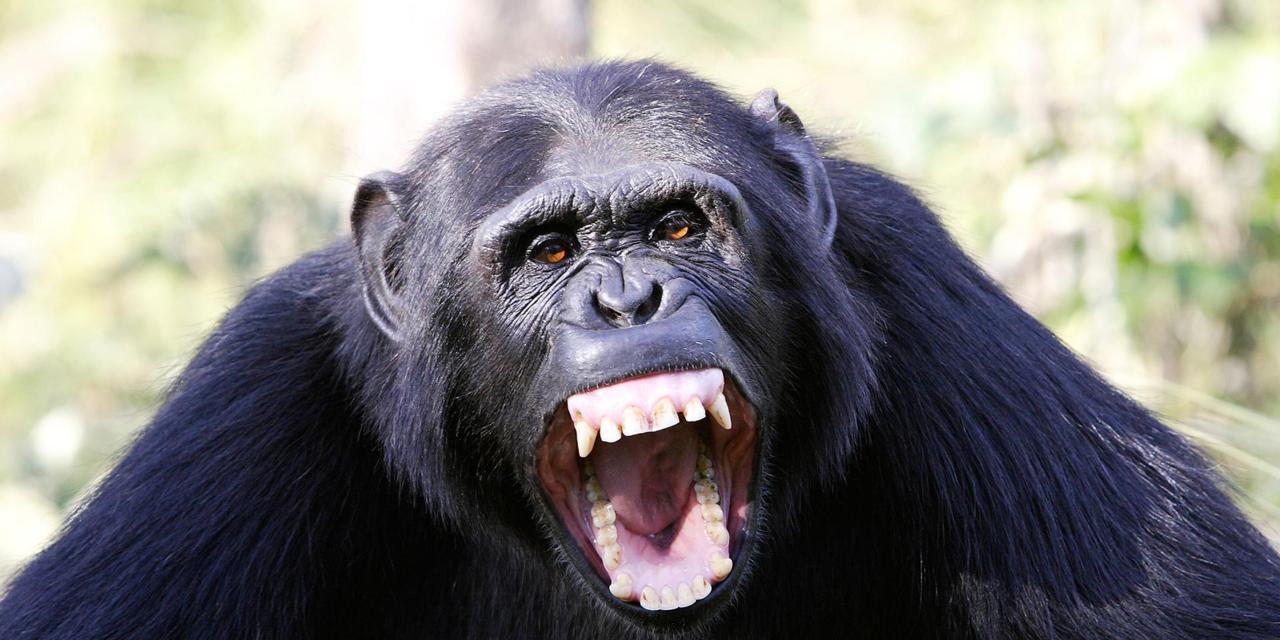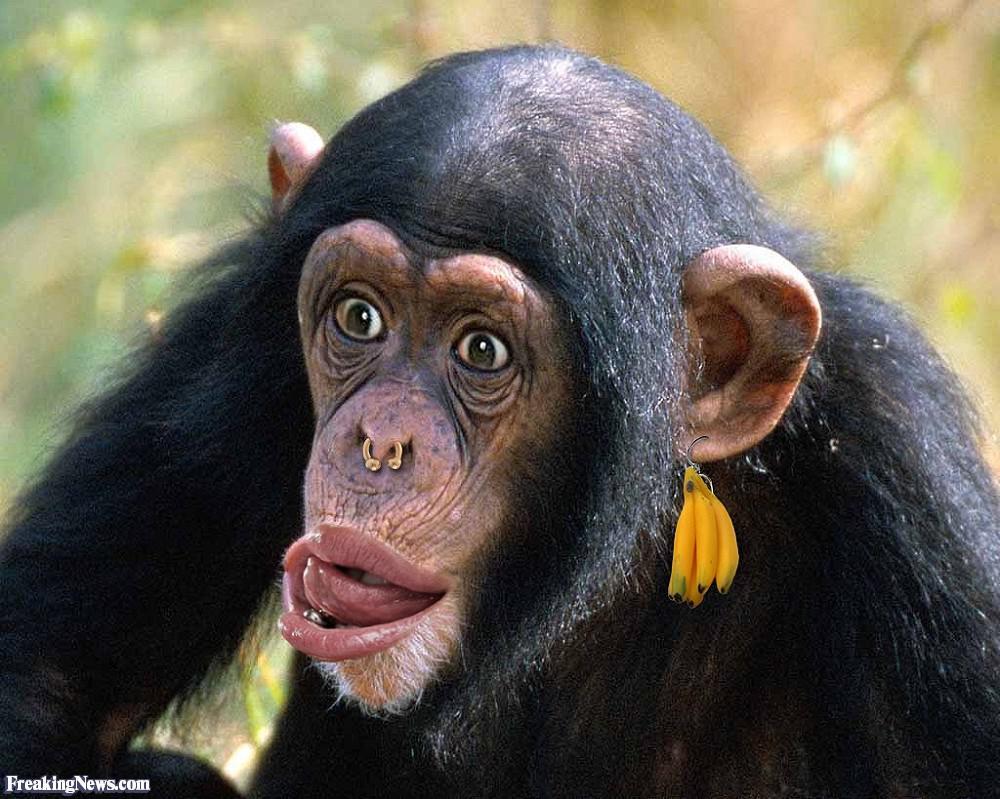The first image is the image on the left, the second image is the image on the right. For the images shown, is this caption "One animal in the image on the left is baring its teeth." true? Answer yes or no. Yes. The first image is the image on the left, the second image is the image on the right. Considering the images on both sides, is "An image includes a camera-facing chimp with a wide-open mouth showing at least one row of teeth." valid? Answer yes or no. Yes. 